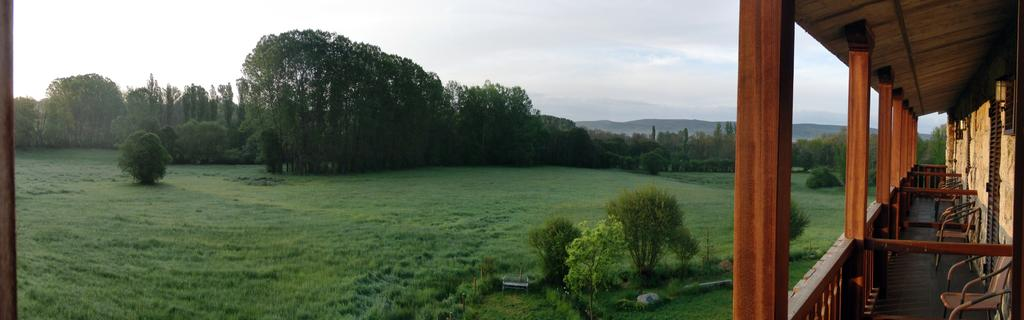What type of vegetation can be seen in the image? There is grass in the image. What other natural elements are present in the image? There are trees in the image. What man-made structures can be seen in the image? There are wooden poles, a wall, and a fence in the image. What can be seen in the distance in the image? There are hills visible in the background of the image. What part of the natural environment is visible in the image? The sky is visible in the background of the image. How many suns are visible in the image? There is no sun visible in the image; only the sky is visible in the background. What is the amount of traffic in the downtown area shown in the image? There is no downtown area or traffic present in the image. 